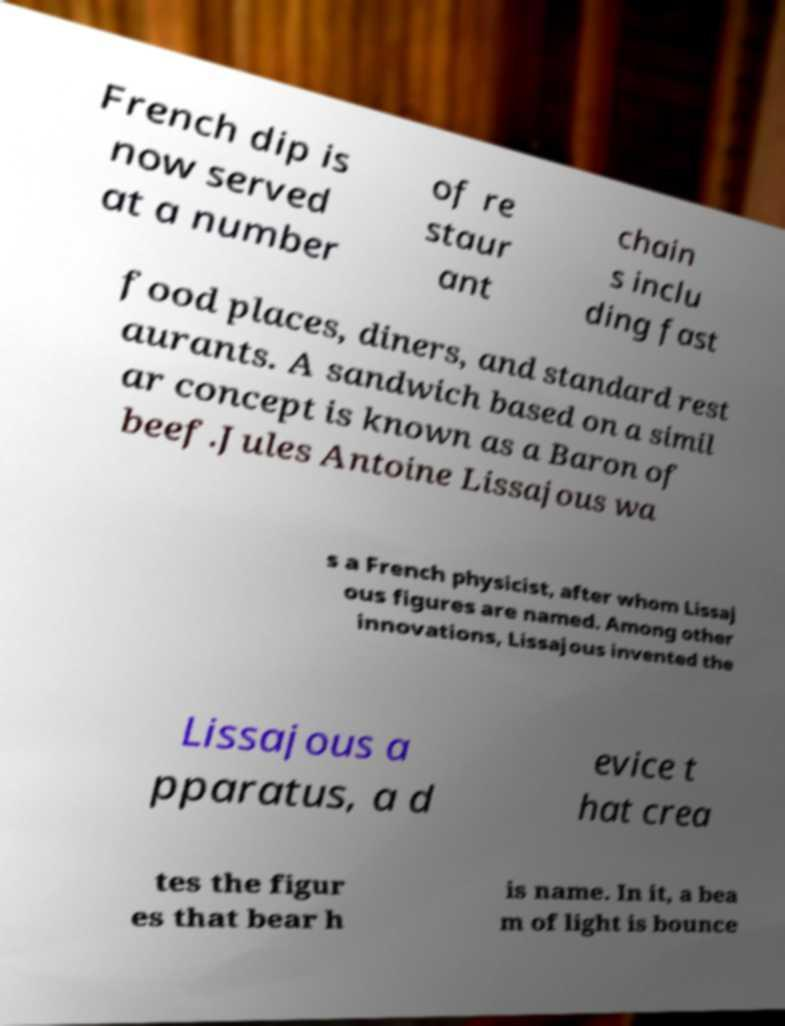I need the written content from this picture converted into text. Can you do that? French dip is now served at a number of re staur ant chain s inclu ding fast food places, diners, and standard rest aurants. A sandwich based on a simil ar concept is known as a Baron of beef.Jules Antoine Lissajous wa s a French physicist, after whom Lissaj ous figures are named. Among other innovations, Lissajous invented the Lissajous a pparatus, a d evice t hat crea tes the figur es that bear h is name. In it, a bea m of light is bounce 